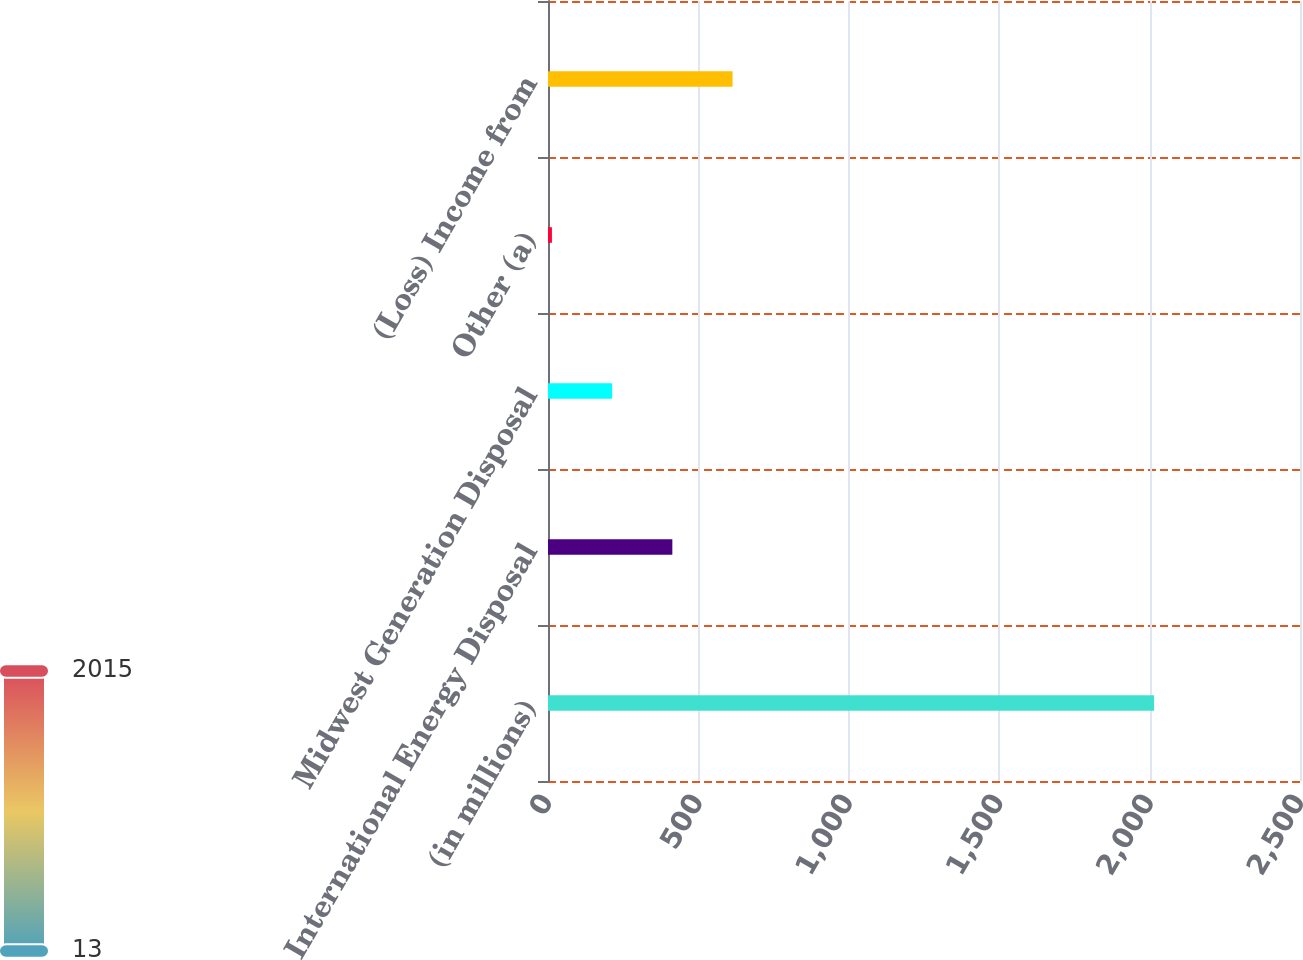Convert chart to OTSL. <chart><loc_0><loc_0><loc_500><loc_500><bar_chart><fcel>(in millions)<fcel>International Energy Disposal<fcel>Midwest Generation Disposal<fcel>Other (a)<fcel>(Loss) Income from<nl><fcel>2015<fcel>413.4<fcel>213.2<fcel>13<fcel>613.6<nl></chart> 